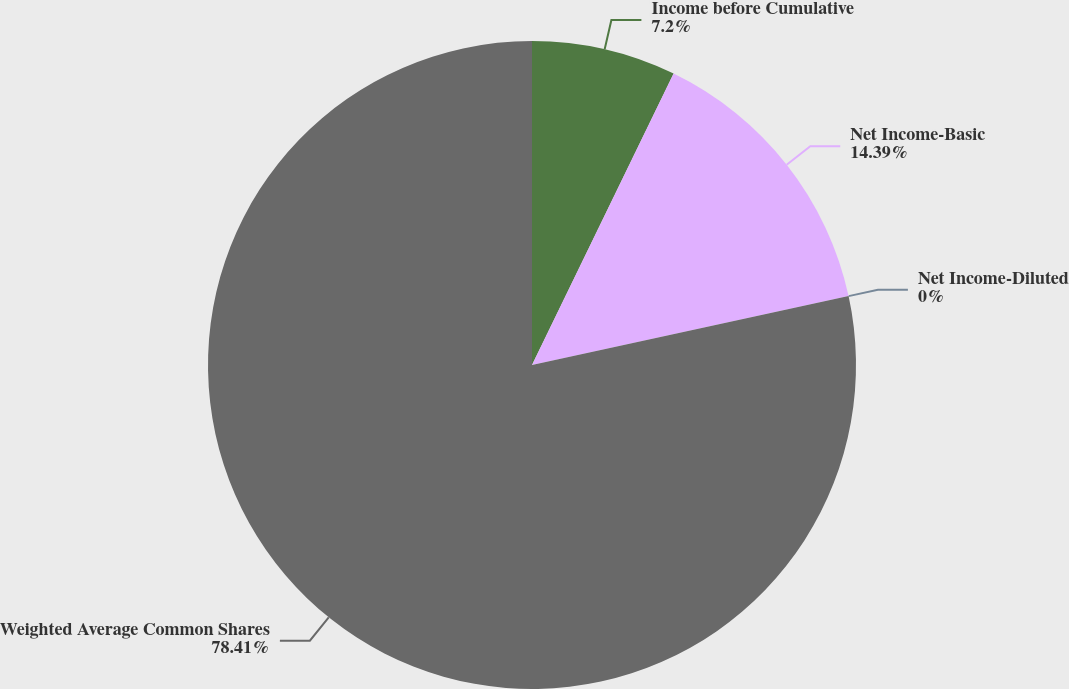Convert chart to OTSL. <chart><loc_0><loc_0><loc_500><loc_500><pie_chart><fcel>Income before Cumulative<fcel>Net Income-Basic<fcel>Net Income-Diluted<fcel>Weighted Average Common Shares<nl><fcel>7.2%<fcel>14.39%<fcel>0.0%<fcel>78.41%<nl></chart> 